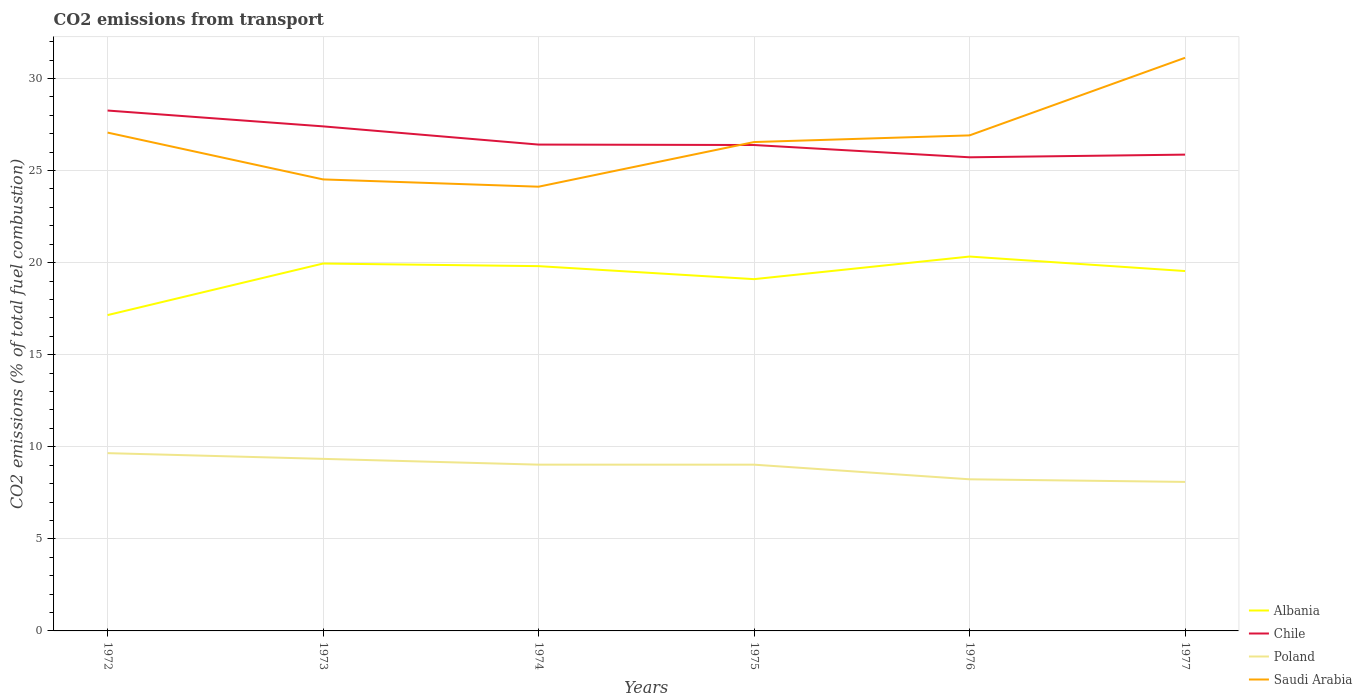Does the line corresponding to Albania intersect with the line corresponding to Poland?
Provide a short and direct response. No. Is the number of lines equal to the number of legend labels?
Ensure brevity in your answer.  Yes. Across all years, what is the maximum total CO2 emitted in Albania?
Your answer should be compact. 17.15. In which year was the total CO2 emitted in Saudi Arabia maximum?
Your response must be concise. 1974. What is the total total CO2 emitted in Saudi Arabia in the graph?
Provide a short and direct response. -2.79. What is the difference between the highest and the second highest total CO2 emitted in Chile?
Offer a very short reply. 2.54. What is the difference between the highest and the lowest total CO2 emitted in Albania?
Your response must be concise. 4. Where does the legend appear in the graph?
Ensure brevity in your answer.  Bottom right. How are the legend labels stacked?
Your answer should be very brief. Vertical. What is the title of the graph?
Your response must be concise. CO2 emissions from transport. Does "Libya" appear as one of the legend labels in the graph?
Keep it short and to the point. No. What is the label or title of the Y-axis?
Ensure brevity in your answer.  CO2 emissions (% of total fuel combustion). What is the CO2 emissions (% of total fuel combustion) of Albania in 1972?
Your answer should be very brief. 17.15. What is the CO2 emissions (% of total fuel combustion) of Chile in 1972?
Your answer should be compact. 28.26. What is the CO2 emissions (% of total fuel combustion) in Poland in 1972?
Provide a succinct answer. 9.65. What is the CO2 emissions (% of total fuel combustion) in Saudi Arabia in 1972?
Ensure brevity in your answer.  27.06. What is the CO2 emissions (% of total fuel combustion) in Albania in 1973?
Provide a short and direct response. 19.95. What is the CO2 emissions (% of total fuel combustion) in Chile in 1973?
Offer a terse response. 27.4. What is the CO2 emissions (% of total fuel combustion) in Poland in 1973?
Your answer should be very brief. 9.34. What is the CO2 emissions (% of total fuel combustion) in Saudi Arabia in 1973?
Ensure brevity in your answer.  24.52. What is the CO2 emissions (% of total fuel combustion) in Albania in 1974?
Provide a short and direct response. 19.81. What is the CO2 emissions (% of total fuel combustion) in Chile in 1974?
Your response must be concise. 26.41. What is the CO2 emissions (% of total fuel combustion) of Poland in 1974?
Ensure brevity in your answer.  9.03. What is the CO2 emissions (% of total fuel combustion) in Saudi Arabia in 1974?
Offer a very short reply. 24.12. What is the CO2 emissions (% of total fuel combustion) of Albania in 1975?
Provide a short and direct response. 19.1. What is the CO2 emissions (% of total fuel combustion) in Chile in 1975?
Your answer should be compact. 26.38. What is the CO2 emissions (% of total fuel combustion) in Poland in 1975?
Provide a short and direct response. 9.03. What is the CO2 emissions (% of total fuel combustion) in Saudi Arabia in 1975?
Provide a short and direct response. 26.55. What is the CO2 emissions (% of total fuel combustion) of Albania in 1976?
Your response must be concise. 20.33. What is the CO2 emissions (% of total fuel combustion) of Chile in 1976?
Your answer should be compact. 25.72. What is the CO2 emissions (% of total fuel combustion) in Poland in 1976?
Give a very brief answer. 8.23. What is the CO2 emissions (% of total fuel combustion) in Saudi Arabia in 1976?
Provide a succinct answer. 26.91. What is the CO2 emissions (% of total fuel combustion) of Albania in 1977?
Ensure brevity in your answer.  19.54. What is the CO2 emissions (% of total fuel combustion) of Chile in 1977?
Ensure brevity in your answer.  25.86. What is the CO2 emissions (% of total fuel combustion) of Poland in 1977?
Ensure brevity in your answer.  8.09. What is the CO2 emissions (% of total fuel combustion) in Saudi Arabia in 1977?
Offer a very short reply. 31.12. Across all years, what is the maximum CO2 emissions (% of total fuel combustion) of Albania?
Provide a succinct answer. 20.33. Across all years, what is the maximum CO2 emissions (% of total fuel combustion) in Chile?
Ensure brevity in your answer.  28.26. Across all years, what is the maximum CO2 emissions (% of total fuel combustion) of Poland?
Keep it short and to the point. 9.65. Across all years, what is the maximum CO2 emissions (% of total fuel combustion) of Saudi Arabia?
Give a very brief answer. 31.12. Across all years, what is the minimum CO2 emissions (% of total fuel combustion) in Albania?
Your answer should be compact. 17.15. Across all years, what is the minimum CO2 emissions (% of total fuel combustion) of Chile?
Your response must be concise. 25.72. Across all years, what is the minimum CO2 emissions (% of total fuel combustion) in Poland?
Offer a very short reply. 8.09. Across all years, what is the minimum CO2 emissions (% of total fuel combustion) in Saudi Arabia?
Give a very brief answer. 24.12. What is the total CO2 emissions (% of total fuel combustion) in Albania in the graph?
Your response must be concise. 115.87. What is the total CO2 emissions (% of total fuel combustion) of Chile in the graph?
Ensure brevity in your answer.  160.02. What is the total CO2 emissions (% of total fuel combustion) in Poland in the graph?
Keep it short and to the point. 53.38. What is the total CO2 emissions (% of total fuel combustion) of Saudi Arabia in the graph?
Keep it short and to the point. 160.27. What is the difference between the CO2 emissions (% of total fuel combustion) of Albania in 1972 and that in 1973?
Ensure brevity in your answer.  -2.8. What is the difference between the CO2 emissions (% of total fuel combustion) of Chile in 1972 and that in 1973?
Make the answer very short. 0.86. What is the difference between the CO2 emissions (% of total fuel combustion) of Poland in 1972 and that in 1973?
Your answer should be compact. 0.31. What is the difference between the CO2 emissions (% of total fuel combustion) of Saudi Arabia in 1972 and that in 1973?
Offer a very short reply. 2.54. What is the difference between the CO2 emissions (% of total fuel combustion) in Albania in 1972 and that in 1974?
Give a very brief answer. -2.66. What is the difference between the CO2 emissions (% of total fuel combustion) in Chile in 1972 and that in 1974?
Give a very brief answer. 1.85. What is the difference between the CO2 emissions (% of total fuel combustion) in Poland in 1972 and that in 1974?
Give a very brief answer. 0.62. What is the difference between the CO2 emissions (% of total fuel combustion) of Saudi Arabia in 1972 and that in 1974?
Give a very brief answer. 2.94. What is the difference between the CO2 emissions (% of total fuel combustion) in Albania in 1972 and that in 1975?
Provide a short and direct response. -1.95. What is the difference between the CO2 emissions (% of total fuel combustion) in Chile in 1972 and that in 1975?
Your answer should be very brief. 1.87. What is the difference between the CO2 emissions (% of total fuel combustion) in Poland in 1972 and that in 1975?
Offer a terse response. 0.63. What is the difference between the CO2 emissions (% of total fuel combustion) of Saudi Arabia in 1972 and that in 1975?
Your answer should be very brief. 0.51. What is the difference between the CO2 emissions (% of total fuel combustion) in Albania in 1972 and that in 1976?
Ensure brevity in your answer.  -3.18. What is the difference between the CO2 emissions (% of total fuel combustion) in Chile in 1972 and that in 1976?
Offer a very short reply. 2.54. What is the difference between the CO2 emissions (% of total fuel combustion) of Poland in 1972 and that in 1976?
Ensure brevity in your answer.  1.42. What is the difference between the CO2 emissions (% of total fuel combustion) of Saudi Arabia in 1972 and that in 1976?
Your response must be concise. 0.15. What is the difference between the CO2 emissions (% of total fuel combustion) of Albania in 1972 and that in 1977?
Offer a very short reply. -2.39. What is the difference between the CO2 emissions (% of total fuel combustion) in Chile in 1972 and that in 1977?
Ensure brevity in your answer.  2.39. What is the difference between the CO2 emissions (% of total fuel combustion) of Poland in 1972 and that in 1977?
Provide a short and direct response. 1.56. What is the difference between the CO2 emissions (% of total fuel combustion) of Saudi Arabia in 1972 and that in 1977?
Offer a very short reply. -4.06. What is the difference between the CO2 emissions (% of total fuel combustion) of Albania in 1973 and that in 1974?
Offer a very short reply. 0.14. What is the difference between the CO2 emissions (% of total fuel combustion) in Chile in 1973 and that in 1974?
Your answer should be compact. 0.99. What is the difference between the CO2 emissions (% of total fuel combustion) in Poland in 1973 and that in 1974?
Provide a succinct answer. 0.31. What is the difference between the CO2 emissions (% of total fuel combustion) of Saudi Arabia in 1973 and that in 1974?
Give a very brief answer. 0.4. What is the difference between the CO2 emissions (% of total fuel combustion) in Albania in 1973 and that in 1975?
Your answer should be compact. 0.85. What is the difference between the CO2 emissions (% of total fuel combustion) in Chile in 1973 and that in 1975?
Offer a terse response. 1.01. What is the difference between the CO2 emissions (% of total fuel combustion) of Poland in 1973 and that in 1975?
Make the answer very short. 0.32. What is the difference between the CO2 emissions (% of total fuel combustion) in Saudi Arabia in 1973 and that in 1975?
Make the answer very short. -2.03. What is the difference between the CO2 emissions (% of total fuel combustion) of Albania in 1973 and that in 1976?
Your response must be concise. -0.38. What is the difference between the CO2 emissions (% of total fuel combustion) of Chile in 1973 and that in 1976?
Provide a short and direct response. 1.68. What is the difference between the CO2 emissions (% of total fuel combustion) in Poland in 1973 and that in 1976?
Keep it short and to the point. 1.11. What is the difference between the CO2 emissions (% of total fuel combustion) of Saudi Arabia in 1973 and that in 1976?
Provide a succinct answer. -2.39. What is the difference between the CO2 emissions (% of total fuel combustion) in Albania in 1973 and that in 1977?
Offer a very short reply. 0.41. What is the difference between the CO2 emissions (% of total fuel combustion) of Chile in 1973 and that in 1977?
Your answer should be very brief. 1.53. What is the difference between the CO2 emissions (% of total fuel combustion) in Poland in 1973 and that in 1977?
Provide a succinct answer. 1.25. What is the difference between the CO2 emissions (% of total fuel combustion) in Saudi Arabia in 1973 and that in 1977?
Offer a terse response. -6.6. What is the difference between the CO2 emissions (% of total fuel combustion) of Albania in 1974 and that in 1975?
Make the answer very short. 0.71. What is the difference between the CO2 emissions (% of total fuel combustion) in Chile in 1974 and that in 1975?
Provide a succinct answer. 0.02. What is the difference between the CO2 emissions (% of total fuel combustion) in Poland in 1974 and that in 1975?
Offer a very short reply. 0. What is the difference between the CO2 emissions (% of total fuel combustion) of Saudi Arabia in 1974 and that in 1975?
Offer a very short reply. -2.42. What is the difference between the CO2 emissions (% of total fuel combustion) in Albania in 1974 and that in 1976?
Your answer should be very brief. -0.52. What is the difference between the CO2 emissions (% of total fuel combustion) of Chile in 1974 and that in 1976?
Keep it short and to the point. 0.69. What is the difference between the CO2 emissions (% of total fuel combustion) of Poland in 1974 and that in 1976?
Offer a very short reply. 0.79. What is the difference between the CO2 emissions (% of total fuel combustion) in Saudi Arabia in 1974 and that in 1976?
Your response must be concise. -2.79. What is the difference between the CO2 emissions (% of total fuel combustion) of Albania in 1974 and that in 1977?
Your response must be concise. 0.27. What is the difference between the CO2 emissions (% of total fuel combustion) in Chile in 1974 and that in 1977?
Your response must be concise. 0.55. What is the difference between the CO2 emissions (% of total fuel combustion) of Poland in 1974 and that in 1977?
Offer a very short reply. 0.94. What is the difference between the CO2 emissions (% of total fuel combustion) in Saudi Arabia in 1974 and that in 1977?
Your answer should be compact. -7. What is the difference between the CO2 emissions (% of total fuel combustion) of Albania in 1975 and that in 1976?
Your answer should be very brief. -1.23. What is the difference between the CO2 emissions (% of total fuel combustion) of Chile in 1975 and that in 1976?
Your response must be concise. 0.67. What is the difference between the CO2 emissions (% of total fuel combustion) in Poland in 1975 and that in 1976?
Offer a very short reply. 0.79. What is the difference between the CO2 emissions (% of total fuel combustion) in Saudi Arabia in 1975 and that in 1976?
Provide a succinct answer. -0.36. What is the difference between the CO2 emissions (% of total fuel combustion) of Albania in 1975 and that in 1977?
Make the answer very short. -0.44. What is the difference between the CO2 emissions (% of total fuel combustion) in Chile in 1975 and that in 1977?
Give a very brief answer. 0.52. What is the difference between the CO2 emissions (% of total fuel combustion) in Poland in 1975 and that in 1977?
Make the answer very short. 0.94. What is the difference between the CO2 emissions (% of total fuel combustion) of Saudi Arabia in 1975 and that in 1977?
Provide a short and direct response. -4.58. What is the difference between the CO2 emissions (% of total fuel combustion) in Albania in 1976 and that in 1977?
Your answer should be very brief. 0.79. What is the difference between the CO2 emissions (% of total fuel combustion) of Chile in 1976 and that in 1977?
Provide a succinct answer. -0.14. What is the difference between the CO2 emissions (% of total fuel combustion) in Poland in 1976 and that in 1977?
Offer a very short reply. 0.14. What is the difference between the CO2 emissions (% of total fuel combustion) of Saudi Arabia in 1976 and that in 1977?
Your response must be concise. -4.21. What is the difference between the CO2 emissions (% of total fuel combustion) in Albania in 1972 and the CO2 emissions (% of total fuel combustion) in Chile in 1973?
Ensure brevity in your answer.  -10.25. What is the difference between the CO2 emissions (% of total fuel combustion) of Albania in 1972 and the CO2 emissions (% of total fuel combustion) of Poland in 1973?
Give a very brief answer. 7.81. What is the difference between the CO2 emissions (% of total fuel combustion) in Albania in 1972 and the CO2 emissions (% of total fuel combustion) in Saudi Arabia in 1973?
Provide a succinct answer. -7.37. What is the difference between the CO2 emissions (% of total fuel combustion) in Chile in 1972 and the CO2 emissions (% of total fuel combustion) in Poland in 1973?
Give a very brief answer. 18.91. What is the difference between the CO2 emissions (% of total fuel combustion) in Chile in 1972 and the CO2 emissions (% of total fuel combustion) in Saudi Arabia in 1973?
Your answer should be compact. 3.74. What is the difference between the CO2 emissions (% of total fuel combustion) in Poland in 1972 and the CO2 emissions (% of total fuel combustion) in Saudi Arabia in 1973?
Ensure brevity in your answer.  -14.86. What is the difference between the CO2 emissions (% of total fuel combustion) in Albania in 1972 and the CO2 emissions (% of total fuel combustion) in Chile in 1974?
Provide a short and direct response. -9.26. What is the difference between the CO2 emissions (% of total fuel combustion) of Albania in 1972 and the CO2 emissions (% of total fuel combustion) of Poland in 1974?
Your answer should be very brief. 8.12. What is the difference between the CO2 emissions (% of total fuel combustion) of Albania in 1972 and the CO2 emissions (% of total fuel combustion) of Saudi Arabia in 1974?
Make the answer very short. -6.97. What is the difference between the CO2 emissions (% of total fuel combustion) in Chile in 1972 and the CO2 emissions (% of total fuel combustion) in Poland in 1974?
Offer a very short reply. 19.23. What is the difference between the CO2 emissions (% of total fuel combustion) in Chile in 1972 and the CO2 emissions (% of total fuel combustion) in Saudi Arabia in 1974?
Your response must be concise. 4.14. What is the difference between the CO2 emissions (% of total fuel combustion) of Poland in 1972 and the CO2 emissions (% of total fuel combustion) of Saudi Arabia in 1974?
Keep it short and to the point. -14.47. What is the difference between the CO2 emissions (% of total fuel combustion) in Albania in 1972 and the CO2 emissions (% of total fuel combustion) in Chile in 1975?
Ensure brevity in your answer.  -9.23. What is the difference between the CO2 emissions (% of total fuel combustion) in Albania in 1972 and the CO2 emissions (% of total fuel combustion) in Poland in 1975?
Make the answer very short. 8.12. What is the difference between the CO2 emissions (% of total fuel combustion) in Albania in 1972 and the CO2 emissions (% of total fuel combustion) in Saudi Arabia in 1975?
Offer a terse response. -9.4. What is the difference between the CO2 emissions (% of total fuel combustion) in Chile in 1972 and the CO2 emissions (% of total fuel combustion) in Poland in 1975?
Your response must be concise. 19.23. What is the difference between the CO2 emissions (% of total fuel combustion) in Chile in 1972 and the CO2 emissions (% of total fuel combustion) in Saudi Arabia in 1975?
Offer a terse response. 1.71. What is the difference between the CO2 emissions (% of total fuel combustion) in Poland in 1972 and the CO2 emissions (% of total fuel combustion) in Saudi Arabia in 1975?
Give a very brief answer. -16.89. What is the difference between the CO2 emissions (% of total fuel combustion) of Albania in 1972 and the CO2 emissions (% of total fuel combustion) of Chile in 1976?
Your answer should be compact. -8.57. What is the difference between the CO2 emissions (% of total fuel combustion) in Albania in 1972 and the CO2 emissions (% of total fuel combustion) in Poland in 1976?
Ensure brevity in your answer.  8.92. What is the difference between the CO2 emissions (% of total fuel combustion) in Albania in 1972 and the CO2 emissions (% of total fuel combustion) in Saudi Arabia in 1976?
Give a very brief answer. -9.76. What is the difference between the CO2 emissions (% of total fuel combustion) of Chile in 1972 and the CO2 emissions (% of total fuel combustion) of Poland in 1976?
Offer a terse response. 20.02. What is the difference between the CO2 emissions (% of total fuel combustion) in Chile in 1972 and the CO2 emissions (% of total fuel combustion) in Saudi Arabia in 1976?
Your answer should be very brief. 1.35. What is the difference between the CO2 emissions (% of total fuel combustion) of Poland in 1972 and the CO2 emissions (% of total fuel combustion) of Saudi Arabia in 1976?
Provide a succinct answer. -17.25. What is the difference between the CO2 emissions (% of total fuel combustion) of Albania in 1972 and the CO2 emissions (% of total fuel combustion) of Chile in 1977?
Provide a succinct answer. -8.71. What is the difference between the CO2 emissions (% of total fuel combustion) in Albania in 1972 and the CO2 emissions (% of total fuel combustion) in Poland in 1977?
Keep it short and to the point. 9.06. What is the difference between the CO2 emissions (% of total fuel combustion) in Albania in 1972 and the CO2 emissions (% of total fuel combustion) in Saudi Arabia in 1977?
Your answer should be very brief. -13.97. What is the difference between the CO2 emissions (% of total fuel combustion) in Chile in 1972 and the CO2 emissions (% of total fuel combustion) in Poland in 1977?
Offer a very short reply. 20.17. What is the difference between the CO2 emissions (% of total fuel combustion) of Chile in 1972 and the CO2 emissions (% of total fuel combustion) of Saudi Arabia in 1977?
Keep it short and to the point. -2.86. What is the difference between the CO2 emissions (% of total fuel combustion) of Poland in 1972 and the CO2 emissions (% of total fuel combustion) of Saudi Arabia in 1977?
Your response must be concise. -21.47. What is the difference between the CO2 emissions (% of total fuel combustion) of Albania in 1973 and the CO2 emissions (% of total fuel combustion) of Chile in 1974?
Ensure brevity in your answer.  -6.46. What is the difference between the CO2 emissions (% of total fuel combustion) of Albania in 1973 and the CO2 emissions (% of total fuel combustion) of Poland in 1974?
Provide a succinct answer. 10.92. What is the difference between the CO2 emissions (% of total fuel combustion) of Albania in 1973 and the CO2 emissions (% of total fuel combustion) of Saudi Arabia in 1974?
Your answer should be compact. -4.17. What is the difference between the CO2 emissions (% of total fuel combustion) of Chile in 1973 and the CO2 emissions (% of total fuel combustion) of Poland in 1974?
Ensure brevity in your answer.  18.37. What is the difference between the CO2 emissions (% of total fuel combustion) of Chile in 1973 and the CO2 emissions (% of total fuel combustion) of Saudi Arabia in 1974?
Your response must be concise. 3.28. What is the difference between the CO2 emissions (% of total fuel combustion) of Poland in 1973 and the CO2 emissions (% of total fuel combustion) of Saudi Arabia in 1974?
Your answer should be very brief. -14.78. What is the difference between the CO2 emissions (% of total fuel combustion) in Albania in 1973 and the CO2 emissions (% of total fuel combustion) in Chile in 1975?
Make the answer very short. -6.44. What is the difference between the CO2 emissions (% of total fuel combustion) of Albania in 1973 and the CO2 emissions (% of total fuel combustion) of Poland in 1975?
Offer a terse response. 10.92. What is the difference between the CO2 emissions (% of total fuel combustion) of Albania in 1973 and the CO2 emissions (% of total fuel combustion) of Saudi Arabia in 1975?
Your answer should be very brief. -6.6. What is the difference between the CO2 emissions (% of total fuel combustion) in Chile in 1973 and the CO2 emissions (% of total fuel combustion) in Poland in 1975?
Give a very brief answer. 18.37. What is the difference between the CO2 emissions (% of total fuel combustion) in Chile in 1973 and the CO2 emissions (% of total fuel combustion) in Saudi Arabia in 1975?
Your answer should be very brief. 0.85. What is the difference between the CO2 emissions (% of total fuel combustion) of Poland in 1973 and the CO2 emissions (% of total fuel combustion) of Saudi Arabia in 1975?
Your response must be concise. -17.2. What is the difference between the CO2 emissions (% of total fuel combustion) of Albania in 1973 and the CO2 emissions (% of total fuel combustion) of Chile in 1976?
Provide a short and direct response. -5.77. What is the difference between the CO2 emissions (% of total fuel combustion) in Albania in 1973 and the CO2 emissions (% of total fuel combustion) in Poland in 1976?
Offer a very short reply. 11.72. What is the difference between the CO2 emissions (% of total fuel combustion) of Albania in 1973 and the CO2 emissions (% of total fuel combustion) of Saudi Arabia in 1976?
Keep it short and to the point. -6.96. What is the difference between the CO2 emissions (% of total fuel combustion) of Chile in 1973 and the CO2 emissions (% of total fuel combustion) of Poland in 1976?
Give a very brief answer. 19.16. What is the difference between the CO2 emissions (% of total fuel combustion) in Chile in 1973 and the CO2 emissions (% of total fuel combustion) in Saudi Arabia in 1976?
Give a very brief answer. 0.49. What is the difference between the CO2 emissions (% of total fuel combustion) of Poland in 1973 and the CO2 emissions (% of total fuel combustion) of Saudi Arabia in 1976?
Provide a succinct answer. -17.56. What is the difference between the CO2 emissions (% of total fuel combustion) of Albania in 1973 and the CO2 emissions (% of total fuel combustion) of Chile in 1977?
Provide a succinct answer. -5.91. What is the difference between the CO2 emissions (% of total fuel combustion) of Albania in 1973 and the CO2 emissions (% of total fuel combustion) of Poland in 1977?
Your response must be concise. 11.86. What is the difference between the CO2 emissions (% of total fuel combustion) of Albania in 1973 and the CO2 emissions (% of total fuel combustion) of Saudi Arabia in 1977?
Make the answer very short. -11.17. What is the difference between the CO2 emissions (% of total fuel combustion) of Chile in 1973 and the CO2 emissions (% of total fuel combustion) of Poland in 1977?
Your response must be concise. 19.31. What is the difference between the CO2 emissions (% of total fuel combustion) of Chile in 1973 and the CO2 emissions (% of total fuel combustion) of Saudi Arabia in 1977?
Your answer should be compact. -3.72. What is the difference between the CO2 emissions (% of total fuel combustion) of Poland in 1973 and the CO2 emissions (% of total fuel combustion) of Saudi Arabia in 1977?
Offer a very short reply. -21.78. What is the difference between the CO2 emissions (% of total fuel combustion) of Albania in 1974 and the CO2 emissions (% of total fuel combustion) of Chile in 1975?
Your answer should be very brief. -6.58. What is the difference between the CO2 emissions (% of total fuel combustion) of Albania in 1974 and the CO2 emissions (% of total fuel combustion) of Poland in 1975?
Your answer should be compact. 10.78. What is the difference between the CO2 emissions (% of total fuel combustion) of Albania in 1974 and the CO2 emissions (% of total fuel combustion) of Saudi Arabia in 1975?
Your answer should be compact. -6.74. What is the difference between the CO2 emissions (% of total fuel combustion) in Chile in 1974 and the CO2 emissions (% of total fuel combustion) in Poland in 1975?
Make the answer very short. 17.38. What is the difference between the CO2 emissions (% of total fuel combustion) in Chile in 1974 and the CO2 emissions (% of total fuel combustion) in Saudi Arabia in 1975?
Your response must be concise. -0.14. What is the difference between the CO2 emissions (% of total fuel combustion) of Poland in 1974 and the CO2 emissions (% of total fuel combustion) of Saudi Arabia in 1975?
Make the answer very short. -17.52. What is the difference between the CO2 emissions (% of total fuel combustion) in Albania in 1974 and the CO2 emissions (% of total fuel combustion) in Chile in 1976?
Make the answer very short. -5.91. What is the difference between the CO2 emissions (% of total fuel combustion) of Albania in 1974 and the CO2 emissions (% of total fuel combustion) of Poland in 1976?
Your answer should be very brief. 11.57. What is the difference between the CO2 emissions (% of total fuel combustion) of Albania in 1974 and the CO2 emissions (% of total fuel combustion) of Saudi Arabia in 1976?
Your response must be concise. -7.1. What is the difference between the CO2 emissions (% of total fuel combustion) of Chile in 1974 and the CO2 emissions (% of total fuel combustion) of Poland in 1976?
Your answer should be very brief. 18.17. What is the difference between the CO2 emissions (% of total fuel combustion) in Chile in 1974 and the CO2 emissions (% of total fuel combustion) in Saudi Arabia in 1976?
Your answer should be compact. -0.5. What is the difference between the CO2 emissions (% of total fuel combustion) in Poland in 1974 and the CO2 emissions (% of total fuel combustion) in Saudi Arabia in 1976?
Make the answer very short. -17.88. What is the difference between the CO2 emissions (% of total fuel combustion) of Albania in 1974 and the CO2 emissions (% of total fuel combustion) of Chile in 1977?
Provide a short and direct response. -6.06. What is the difference between the CO2 emissions (% of total fuel combustion) of Albania in 1974 and the CO2 emissions (% of total fuel combustion) of Poland in 1977?
Provide a succinct answer. 11.72. What is the difference between the CO2 emissions (% of total fuel combustion) in Albania in 1974 and the CO2 emissions (% of total fuel combustion) in Saudi Arabia in 1977?
Offer a very short reply. -11.31. What is the difference between the CO2 emissions (% of total fuel combustion) of Chile in 1974 and the CO2 emissions (% of total fuel combustion) of Poland in 1977?
Provide a short and direct response. 18.32. What is the difference between the CO2 emissions (% of total fuel combustion) of Chile in 1974 and the CO2 emissions (% of total fuel combustion) of Saudi Arabia in 1977?
Ensure brevity in your answer.  -4.71. What is the difference between the CO2 emissions (% of total fuel combustion) of Poland in 1974 and the CO2 emissions (% of total fuel combustion) of Saudi Arabia in 1977?
Your answer should be compact. -22.09. What is the difference between the CO2 emissions (% of total fuel combustion) in Albania in 1975 and the CO2 emissions (% of total fuel combustion) in Chile in 1976?
Give a very brief answer. -6.62. What is the difference between the CO2 emissions (% of total fuel combustion) in Albania in 1975 and the CO2 emissions (% of total fuel combustion) in Poland in 1976?
Your answer should be very brief. 10.87. What is the difference between the CO2 emissions (% of total fuel combustion) of Albania in 1975 and the CO2 emissions (% of total fuel combustion) of Saudi Arabia in 1976?
Ensure brevity in your answer.  -7.81. What is the difference between the CO2 emissions (% of total fuel combustion) of Chile in 1975 and the CO2 emissions (% of total fuel combustion) of Poland in 1976?
Provide a succinct answer. 18.15. What is the difference between the CO2 emissions (% of total fuel combustion) in Chile in 1975 and the CO2 emissions (% of total fuel combustion) in Saudi Arabia in 1976?
Keep it short and to the point. -0.52. What is the difference between the CO2 emissions (% of total fuel combustion) in Poland in 1975 and the CO2 emissions (% of total fuel combustion) in Saudi Arabia in 1976?
Offer a terse response. -17.88. What is the difference between the CO2 emissions (% of total fuel combustion) of Albania in 1975 and the CO2 emissions (% of total fuel combustion) of Chile in 1977?
Ensure brevity in your answer.  -6.76. What is the difference between the CO2 emissions (% of total fuel combustion) of Albania in 1975 and the CO2 emissions (% of total fuel combustion) of Poland in 1977?
Provide a short and direct response. 11.01. What is the difference between the CO2 emissions (% of total fuel combustion) in Albania in 1975 and the CO2 emissions (% of total fuel combustion) in Saudi Arabia in 1977?
Provide a short and direct response. -12.02. What is the difference between the CO2 emissions (% of total fuel combustion) of Chile in 1975 and the CO2 emissions (% of total fuel combustion) of Poland in 1977?
Offer a very short reply. 18.29. What is the difference between the CO2 emissions (% of total fuel combustion) in Chile in 1975 and the CO2 emissions (% of total fuel combustion) in Saudi Arabia in 1977?
Your response must be concise. -4.74. What is the difference between the CO2 emissions (% of total fuel combustion) in Poland in 1975 and the CO2 emissions (% of total fuel combustion) in Saudi Arabia in 1977?
Ensure brevity in your answer.  -22.09. What is the difference between the CO2 emissions (% of total fuel combustion) of Albania in 1976 and the CO2 emissions (% of total fuel combustion) of Chile in 1977?
Give a very brief answer. -5.53. What is the difference between the CO2 emissions (% of total fuel combustion) of Albania in 1976 and the CO2 emissions (% of total fuel combustion) of Poland in 1977?
Offer a terse response. 12.24. What is the difference between the CO2 emissions (% of total fuel combustion) of Albania in 1976 and the CO2 emissions (% of total fuel combustion) of Saudi Arabia in 1977?
Give a very brief answer. -10.79. What is the difference between the CO2 emissions (% of total fuel combustion) of Chile in 1976 and the CO2 emissions (% of total fuel combustion) of Poland in 1977?
Offer a terse response. 17.63. What is the difference between the CO2 emissions (% of total fuel combustion) in Chile in 1976 and the CO2 emissions (% of total fuel combustion) in Saudi Arabia in 1977?
Ensure brevity in your answer.  -5.4. What is the difference between the CO2 emissions (% of total fuel combustion) in Poland in 1976 and the CO2 emissions (% of total fuel combustion) in Saudi Arabia in 1977?
Make the answer very short. -22.89. What is the average CO2 emissions (% of total fuel combustion) in Albania per year?
Your answer should be very brief. 19.31. What is the average CO2 emissions (% of total fuel combustion) of Chile per year?
Keep it short and to the point. 26.67. What is the average CO2 emissions (% of total fuel combustion) of Poland per year?
Your answer should be very brief. 8.9. What is the average CO2 emissions (% of total fuel combustion) in Saudi Arabia per year?
Offer a terse response. 26.71. In the year 1972, what is the difference between the CO2 emissions (% of total fuel combustion) of Albania and CO2 emissions (% of total fuel combustion) of Chile?
Keep it short and to the point. -11.11. In the year 1972, what is the difference between the CO2 emissions (% of total fuel combustion) of Albania and CO2 emissions (% of total fuel combustion) of Poland?
Make the answer very short. 7.5. In the year 1972, what is the difference between the CO2 emissions (% of total fuel combustion) in Albania and CO2 emissions (% of total fuel combustion) in Saudi Arabia?
Ensure brevity in your answer.  -9.91. In the year 1972, what is the difference between the CO2 emissions (% of total fuel combustion) of Chile and CO2 emissions (% of total fuel combustion) of Poland?
Provide a short and direct response. 18.6. In the year 1972, what is the difference between the CO2 emissions (% of total fuel combustion) of Chile and CO2 emissions (% of total fuel combustion) of Saudi Arabia?
Ensure brevity in your answer.  1.2. In the year 1972, what is the difference between the CO2 emissions (% of total fuel combustion) of Poland and CO2 emissions (% of total fuel combustion) of Saudi Arabia?
Provide a succinct answer. -17.41. In the year 1973, what is the difference between the CO2 emissions (% of total fuel combustion) in Albania and CO2 emissions (% of total fuel combustion) in Chile?
Offer a terse response. -7.45. In the year 1973, what is the difference between the CO2 emissions (% of total fuel combustion) of Albania and CO2 emissions (% of total fuel combustion) of Poland?
Offer a very short reply. 10.61. In the year 1973, what is the difference between the CO2 emissions (% of total fuel combustion) of Albania and CO2 emissions (% of total fuel combustion) of Saudi Arabia?
Your answer should be compact. -4.57. In the year 1973, what is the difference between the CO2 emissions (% of total fuel combustion) of Chile and CO2 emissions (% of total fuel combustion) of Poland?
Provide a short and direct response. 18.05. In the year 1973, what is the difference between the CO2 emissions (% of total fuel combustion) in Chile and CO2 emissions (% of total fuel combustion) in Saudi Arabia?
Give a very brief answer. 2.88. In the year 1973, what is the difference between the CO2 emissions (% of total fuel combustion) of Poland and CO2 emissions (% of total fuel combustion) of Saudi Arabia?
Keep it short and to the point. -15.17. In the year 1974, what is the difference between the CO2 emissions (% of total fuel combustion) of Albania and CO2 emissions (% of total fuel combustion) of Chile?
Ensure brevity in your answer.  -6.6. In the year 1974, what is the difference between the CO2 emissions (% of total fuel combustion) of Albania and CO2 emissions (% of total fuel combustion) of Poland?
Make the answer very short. 10.78. In the year 1974, what is the difference between the CO2 emissions (% of total fuel combustion) of Albania and CO2 emissions (% of total fuel combustion) of Saudi Arabia?
Your answer should be very brief. -4.31. In the year 1974, what is the difference between the CO2 emissions (% of total fuel combustion) in Chile and CO2 emissions (% of total fuel combustion) in Poland?
Offer a terse response. 17.38. In the year 1974, what is the difference between the CO2 emissions (% of total fuel combustion) of Chile and CO2 emissions (% of total fuel combustion) of Saudi Arabia?
Make the answer very short. 2.29. In the year 1974, what is the difference between the CO2 emissions (% of total fuel combustion) of Poland and CO2 emissions (% of total fuel combustion) of Saudi Arabia?
Make the answer very short. -15.09. In the year 1975, what is the difference between the CO2 emissions (% of total fuel combustion) in Albania and CO2 emissions (% of total fuel combustion) in Chile?
Your response must be concise. -7.28. In the year 1975, what is the difference between the CO2 emissions (% of total fuel combustion) in Albania and CO2 emissions (% of total fuel combustion) in Poland?
Give a very brief answer. 10.07. In the year 1975, what is the difference between the CO2 emissions (% of total fuel combustion) in Albania and CO2 emissions (% of total fuel combustion) in Saudi Arabia?
Give a very brief answer. -7.44. In the year 1975, what is the difference between the CO2 emissions (% of total fuel combustion) of Chile and CO2 emissions (% of total fuel combustion) of Poland?
Make the answer very short. 17.36. In the year 1975, what is the difference between the CO2 emissions (% of total fuel combustion) in Chile and CO2 emissions (% of total fuel combustion) in Saudi Arabia?
Ensure brevity in your answer.  -0.16. In the year 1975, what is the difference between the CO2 emissions (% of total fuel combustion) of Poland and CO2 emissions (% of total fuel combustion) of Saudi Arabia?
Your answer should be compact. -17.52. In the year 1976, what is the difference between the CO2 emissions (% of total fuel combustion) in Albania and CO2 emissions (% of total fuel combustion) in Chile?
Offer a terse response. -5.39. In the year 1976, what is the difference between the CO2 emissions (% of total fuel combustion) in Albania and CO2 emissions (% of total fuel combustion) in Poland?
Offer a very short reply. 12.1. In the year 1976, what is the difference between the CO2 emissions (% of total fuel combustion) in Albania and CO2 emissions (% of total fuel combustion) in Saudi Arabia?
Offer a very short reply. -6.58. In the year 1976, what is the difference between the CO2 emissions (% of total fuel combustion) in Chile and CO2 emissions (% of total fuel combustion) in Poland?
Provide a short and direct response. 17.48. In the year 1976, what is the difference between the CO2 emissions (% of total fuel combustion) of Chile and CO2 emissions (% of total fuel combustion) of Saudi Arabia?
Keep it short and to the point. -1.19. In the year 1976, what is the difference between the CO2 emissions (% of total fuel combustion) in Poland and CO2 emissions (% of total fuel combustion) in Saudi Arabia?
Your answer should be compact. -18.67. In the year 1977, what is the difference between the CO2 emissions (% of total fuel combustion) in Albania and CO2 emissions (% of total fuel combustion) in Chile?
Ensure brevity in your answer.  -6.32. In the year 1977, what is the difference between the CO2 emissions (% of total fuel combustion) of Albania and CO2 emissions (% of total fuel combustion) of Poland?
Provide a short and direct response. 11.45. In the year 1977, what is the difference between the CO2 emissions (% of total fuel combustion) of Albania and CO2 emissions (% of total fuel combustion) of Saudi Arabia?
Your answer should be compact. -11.58. In the year 1977, what is the difference between the CO2 emissions (% of total fuel combustion) in Chile and CO2 emissions (% of total fuel combustion) in Poland?
Your answer should be very brief. 17.77. In the year 1977, what is the difference between the CO2 emissions (% of total fuel combustion) in Chile and CO2 emissions (% of total fuel combustion) in Saudi Arabia?
Make the answer very short. -5.26. In the year 1977, what is the difference between the CO2 emissions (% of total fuel combustion) in Poland and CO2 emissions (% of total fuel combustion) in Saudi Arabia?
Provide a short and direct response. -23.03. What is the ratio of the CO2 emissions (% of total fuel combustion) in Albania in 1972 to that in 1973?
Make the answer very short. 0.86. What is the ratio of the CO2 emissions (% of total fuel combustion) of Chile in 1972 to that in 1973?
Your answer should be very brief. 1.03. What is the ratio of the CO2 emissions (% of total fuel combustion) in Poland in 1972 to that in 1973?
Make the answer very short. 1.03. What is the ratio of the CO2 emissions (% of total fuel combustion) of Saudi Arabia in 1972 to that in 1973?
Your answer should be very brief. 1.1. What is the ratio of the CO2 emissions (% of total fuel combustion) of Albania in 1972 to that in 1974?
Give a very brief answer. 0.87. What is the ratio of the CO2 emissions (% of total fuel combustion) in Chile in 1972 to that in 1974?
Give a very brief answer. 1.07. What is the ratio of the CO2 emissions (% of total fuel combustion) in Poland in 1972 to that in 1974?
Give a very brief answer. 1.07. What is the ratio of the CO2 emissions (% of total fuel combustion) of Saudi Arabia in 1972 to that in 1974?
Your answer should be compact. 1.12. What is the ratio of the CO2 emissions (% of total fuel combustion) of Albania in 1972 to that in 1975?
Give a very brief answer. 0.9. What is the ratio of the CO2 emissions (% of total fuel combustion) in Chile in 1972 to that in 1975?
Make the answer very short. 1.07. What is the ratio of the CO2 emissions (% of total fuel combustion) in Poland in 1972 to that in 1975?
Your answer should be very brief. 1.07. What is the ratio of the CO2 emissions (% of total fuel combustion) in Saudi Arabia in 1972 to that in 1975?
Provide a succinct answer. 1.02. What is the ratio of the CO2 emissions (% of total fuel combustion) in Albania in 1972 to that in 1976?
Make the answer very short. 0.84. What is the ratio of the CO2 emissions (% of total fuel combustion) of Chile in 1972 to that in 1976?
Your answer should be compact. 1.1. What is the ratio of the CO2 emissions (% of total fuel combustion) in Poland in 1972 to that in 1976?
Offer a very short reply. 1.17. What is the ratio of the CO2 emissions (% of total fuel combustion) in Saudi Arabia in 1972 to that in 1976?
Provide a succinct answer. 1.01. What is the ratio of the CO2 emissions (% of total fuel combustion) of Albania in 1972 to that in 1977?
Make the answer very short. 0.88. What is the ratio of the CO2 emissions (% of total fuel combustion) in Chile in 1972 to that in 1977?
Make the answer very short. 1.09. What is the ratio of the CO2 emissions (% of total fuel combustion) in Poland in 1972 to that in 1977?
Your answer should be compact. 1.19. What is the ratio of the CO2 emissions (% of total fuel combustion) of Saudi Arabia in 1972 to that in 1977?
Keep it short and to the point. 0.87. What is the ratio of the CO2 emissions (% of total fuel combustion) in Albania in 1973 to that in 1974?
Your response must be concise. 1.01. What is the ratio of the CO2 emissions (% of total fuel combustion) in Chile in 1973 to that in 1974?
Keep it short and to the point. 1.04. What is the ratio of the CO2 emissions (% of total fuel combustion) of Poland in 1973 to that in 1974?
Keep it short and to the point. 1.03. What is the ratio of the CO2 emissions (% of total fuel combustion) of Saudi Arabia in 1973 to that in 1974?
Make the answer very short. 1.02. What is the ratio of the CO2 emissions (% of total fuel combustion) in Albania in 1973 to that in 1975?
Offer a very short reply. 1.04. What is the ratio of the CO2 emissions (% of total fuel combustion) of Chile in 1973 to that in 1975?
Your answer should be compact. 1.04. What is the ratio of the CO2 emissions (% of total fuel combustion) of Poland in 1973 to that in 1975?
Provide a succinct answer. 1.03. What is the ratio of the CO2 emissions (% of total fuel combustion) of Saudi Arabia in 1973 to that in 1975?
Your response must be concise. 0.92. What is the ratio of the CO2 emissions (% of total fuel combustion) in Albania in 1973 to that in 1976?
Provide a succinct answer. 0.98. What is the ratio of the CO2 emissions (% of total fuel combustion) of Chile in 1973 to that in 1976?
Make the answer very short. 1.07. What is the ratio of the CO2 emissions (% of total fuel combustion) in Poland in 1973 to that in 1976?
Ensure brevity in your answer.  1.13. What is the ratio of the CO2 emissions (% of total fuel combustion) in Saudi Arabia in 1973 to that in 1976?
Offer a very short reply. 0.91. What is the ratio of the CO2 emissions (% of total fuel combustion) in Albania in 1973 to that in 1977?
Provide a short and direct response. 1.02. What is the ratio of the CO2 emissions (% of total fuel combustion) in Chile in 1973 to that in 1977?
Provide a succinct answer. 1.06. What is the ratio of the CO2 emissions (% of total fuel combustion) of Poland in 1973 to that in 1977?
Your answer should be very brief. 1.15. What is the ratio of the CO2 emissions (% of total fuel combustion) in Saudi Arabia in 1973 to that in 1977?
Keep it short and to the point. 0.79. What is the ratio of the CO2 emissions (% of total fuel combustion) of Albania in 1974 to that in 1975?
Keep it short and to the point. 1.04. What is the ratio of the CO2 emissions (% of total fuel combustion) of Chile in 1974 to that in 1975?
Make the answer very short. 1. What is the ratio of the CO2 emissions (% of total fuel combustion) of Poland in 1974 to that in 1975?
Your answer should be compact. 1. What is the ratio of the CO2 emissions (% of total fuel combustion) in Saudi Arabia in 1974 to that in 1975?
Provide a short and direct response. 0.91. What is the ratio of the CO2 emissions (% of total fuel combustion) of Albania in 1974 to that in 1976?
Offer a terse response. 0.97. What is the ratio of the CO2 emissions (% of total fuel combustion) of Chile in 1974 to that in 1976?
Offer a very short reply. 1.03. What is the ratio of the CO2 emissions (% of total fuel combustion) of Poland in 1974 to that in 1976?
Your answer should be very brief. 1.1. What is the ratio of the CO2 emissions (% of total fuel combustion) of Saudi Arabia in 1974 to that in 1976?
Your response must be concise. 0.9. What is the ratio of the CO2 emissions (% of total fuel combustion) of Albania in 1974 to that in 1977?
Offer a very short reply. 1.01. What is the ratio of the CO2 emissions (% of total fuel combustion) of Chile in 1974 to that in 1977?
Your answer should be compact. 1.02. What is the ratio of the CO2 emissions (% of total fuel combustion) of Poland in 1974 to that in 1977?
Provide a succinct answer. 1.12. What is the ratio of the CO2 emissions (% of total fuel combustion) of Saudi Arabia in 1974 to that in 1977?
Your answer should be compact. 0.78. What is the ratio of the CO2 emissions (% of total fuel combustion) in Albania in 1975 to that in 1976?
Your answer should be compact. 0.94. What is the ratio of the CO2 emissions (% of total fuel combustion) of Chile in 1975 to that in 1976?
Offer a terse response. 1.03. What is the ratio of the CO2 emissions (% of total fuel combustion) of Poland in 1975 to that in 1976?
Ensure brevity in your answer.  1.1. What is the ratio of the CO2 emissions (% of total fuel combustion) in Saudi Arabia in 1975 to that in 1976?
Ensure brevity in your answer.  0.99. What is the ratio of the CO2 emissions (% of total fuel combustion) in Albania in 1975 to that in 1977?
Provide a short and direct response. 0.98. What is the ratio of the CO2 emissions (% of total fuel combustion) in Chile in 1975 to that in 1977?
Provide a succinct answer. 1.02. What is the ratio of the CO2 emissions (% of total fuel combustion) in Poland in 1975 to that in 1977?
Make the answer very short. 1.12. What is the ratio of the CO2 emissions (% of total fuel combustion) of Saudi Arabia in 1975 to that in 1977?
Provide a short and direct response. 0.85. What is the ratio of the CO2 emissions (% of total fuel combustion) of Albania in 1976 to that in 1977?
Keep it short and to the point. 1.04. What is the ratio of the CO2 emissions (% of total fuel combustion) in Chile in 1976 to that in 1977?
Offer a very short reply. 0.99. What is the ratio of the CO2 emissions (% of total fuel combustion) of Poland in 1976 to that in 1977?
Ensure brevity in your answer.  1.02. What is the ratio of the CO2 emissions (% of total fuel combustion) of Saudi Arabia in 1976 to that in 1977?
Your response must be concise. 0.86. What is the difference between the highest and the second highest CO2 emissions (% of total fuel combustion) in Albania?
Make the answer very short. 0.38. What is the difference between the highest and the second highest CO2 emissions (% of total fuel combustion) of Chile?
Ensure brevity in your answer.  0.86. What is the difference between the highest and the second highest CO2 emissions (% of total fuel combustion) of Poland?
Ensure brevity in your answer.  0.31. What is the difference between the highest and the second highest CO2 emissions (% of total fuel combustion) of Saudi Arabia?
Keep it short and to the point. 4.06. What is the difference between the highest and the lowest CO2 emissions (% of total fuel combustion) in Albania?
Make the answer very short. 3.18. What is the difference between the highest and the lowest CO2 emissions (% of total fuel combustion) in Chile?
Your answer should be very brief. 2.54. What is the difference between the highest and the lowest CO2 emissions (% of total fuel combustion) in Poland?
Provide a succinct answer. 1.56. What is the difference between the highest and the lowest CO2 emissions (% of total fuel combustion) of Saudi Arabia?
Your response must be concise. 7. 